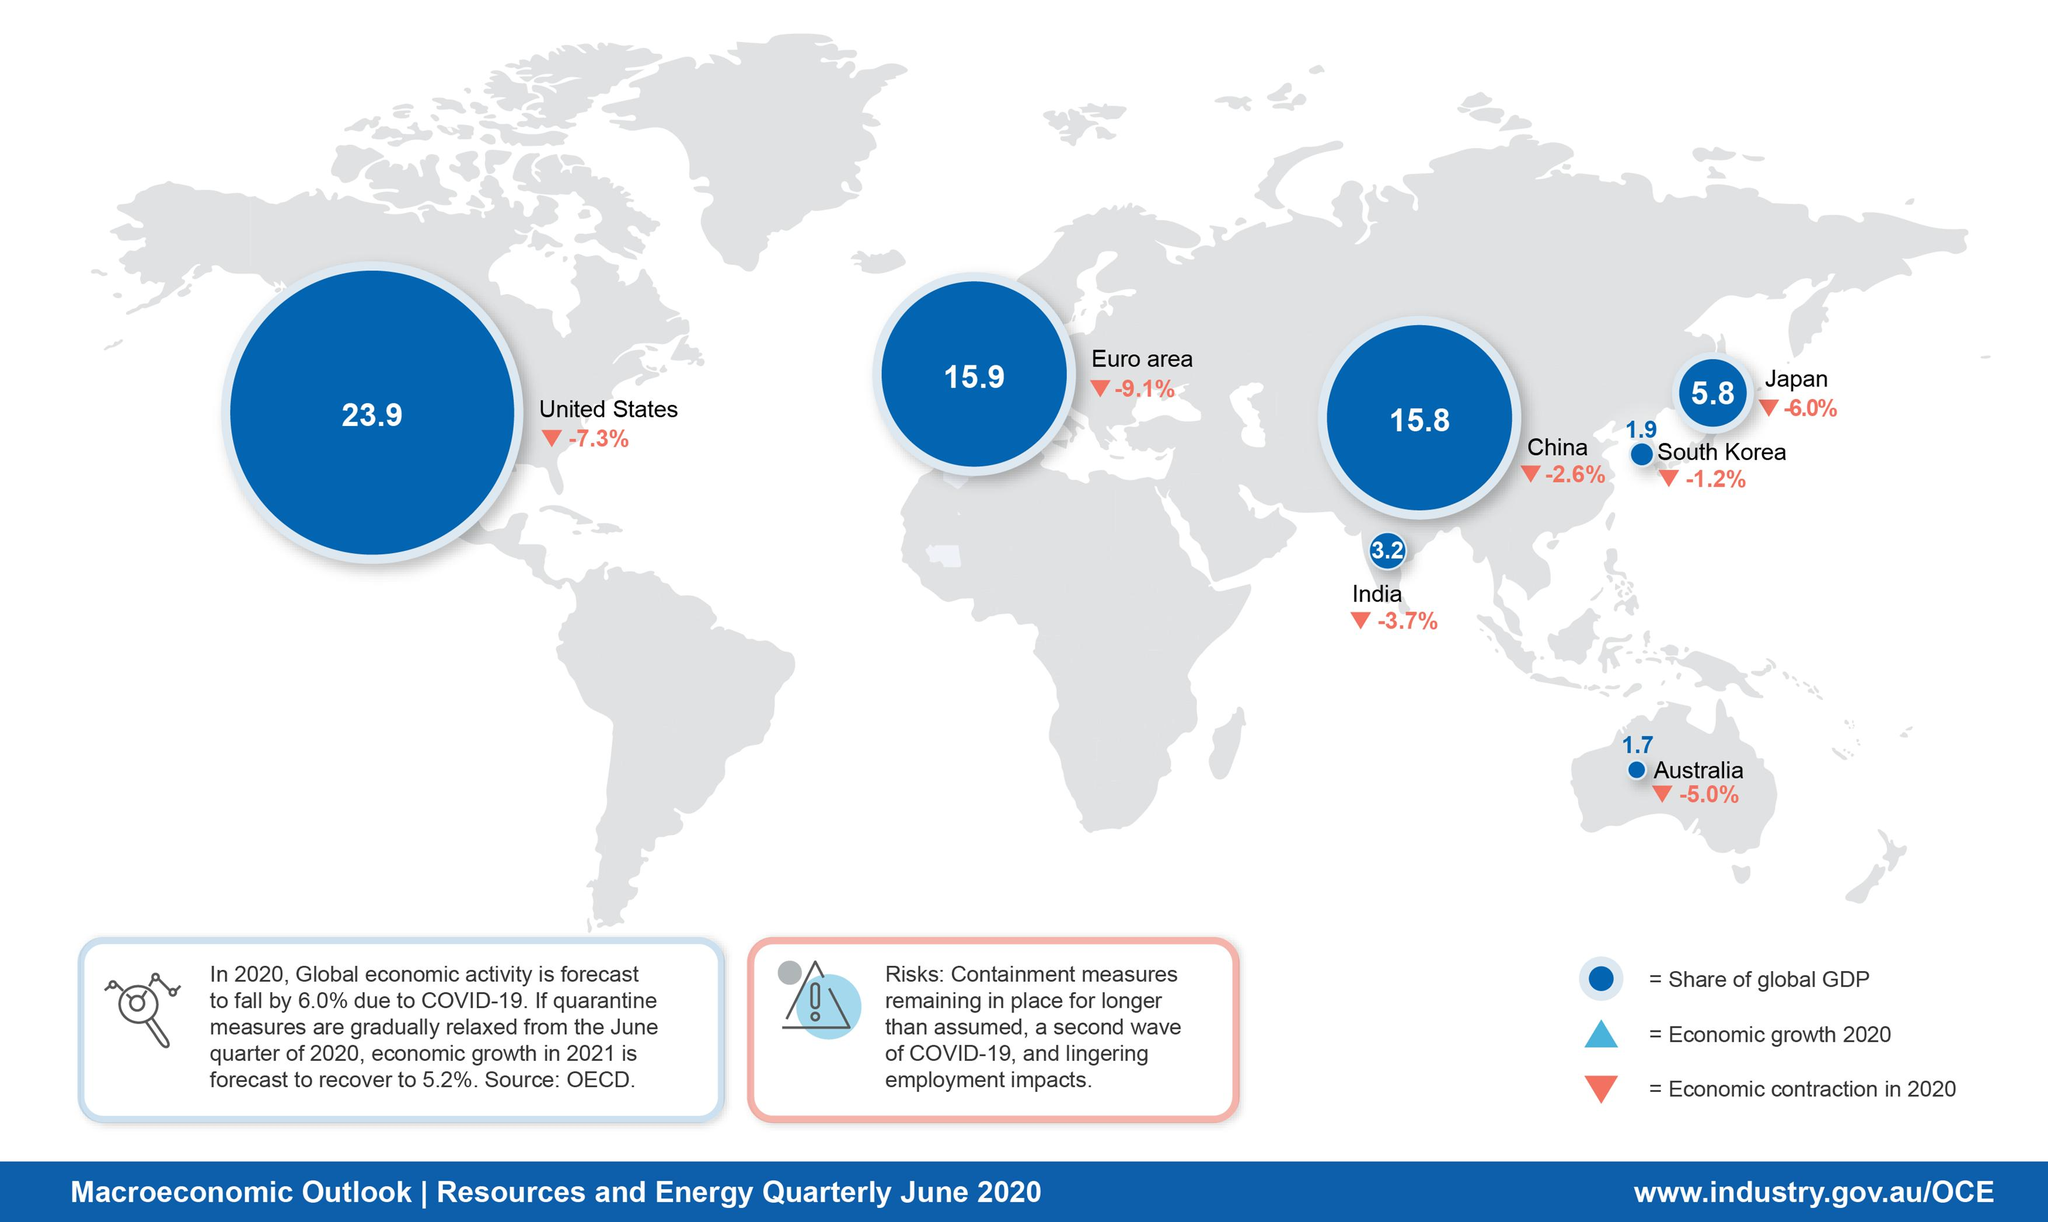Point out several critical features in this image. The economic contraction in China during the quarter of June 2020 was -2.6%. According to the latest data available, India's share of global GDP in the quarter of June 2020 was 3.2%. According to the data, the economy in Australia contracted by 5.0% in the quarter of June 2020. The U.S.'s share of global GDP in the quarter of June 2020 was 23.9%. In the second quarter of 2020, China's share of global GDP was 15.8%. 